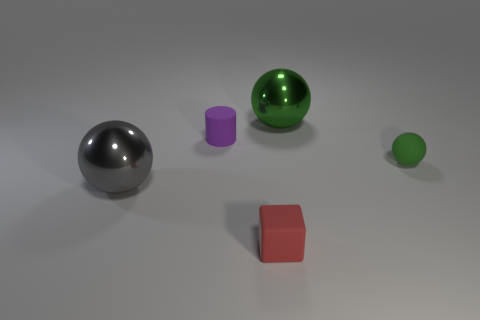What is the color of the big shiny object that is on the left side of the red matte cube?
Keep it short and to the point. Gray. What shape is the green object that is the same size as the red rubber block?
Ensure brevity in your answer.  Sphere. There is a tiny ball; how many objects are behind it?
Offer a very short reply. 2. What number of objects are either tiny green spheres or green cylinders?
Ensure brevity in your answer.  1. There is a rubber thing that is left of the tiny rubber ball and in front of the tiny purple rubber object; what is its shape?
Give a very brief answer. Cube. What number of big blue objects are there?
Provide a succinct answer. 0. What color is the large sphere that is the same material as the gray thing?
Your response must be concise. Green. Is the number of small matte blocks greater than the number of big green rubber balls?
Provide a succinct answer. Yes. How big is the object that is both left of the red cube and in front of the small purple object?
Your answer should be very brief. Large. What is the material of the object that is the same color as the tiny ball?
Give a very brief answer. Metal. 